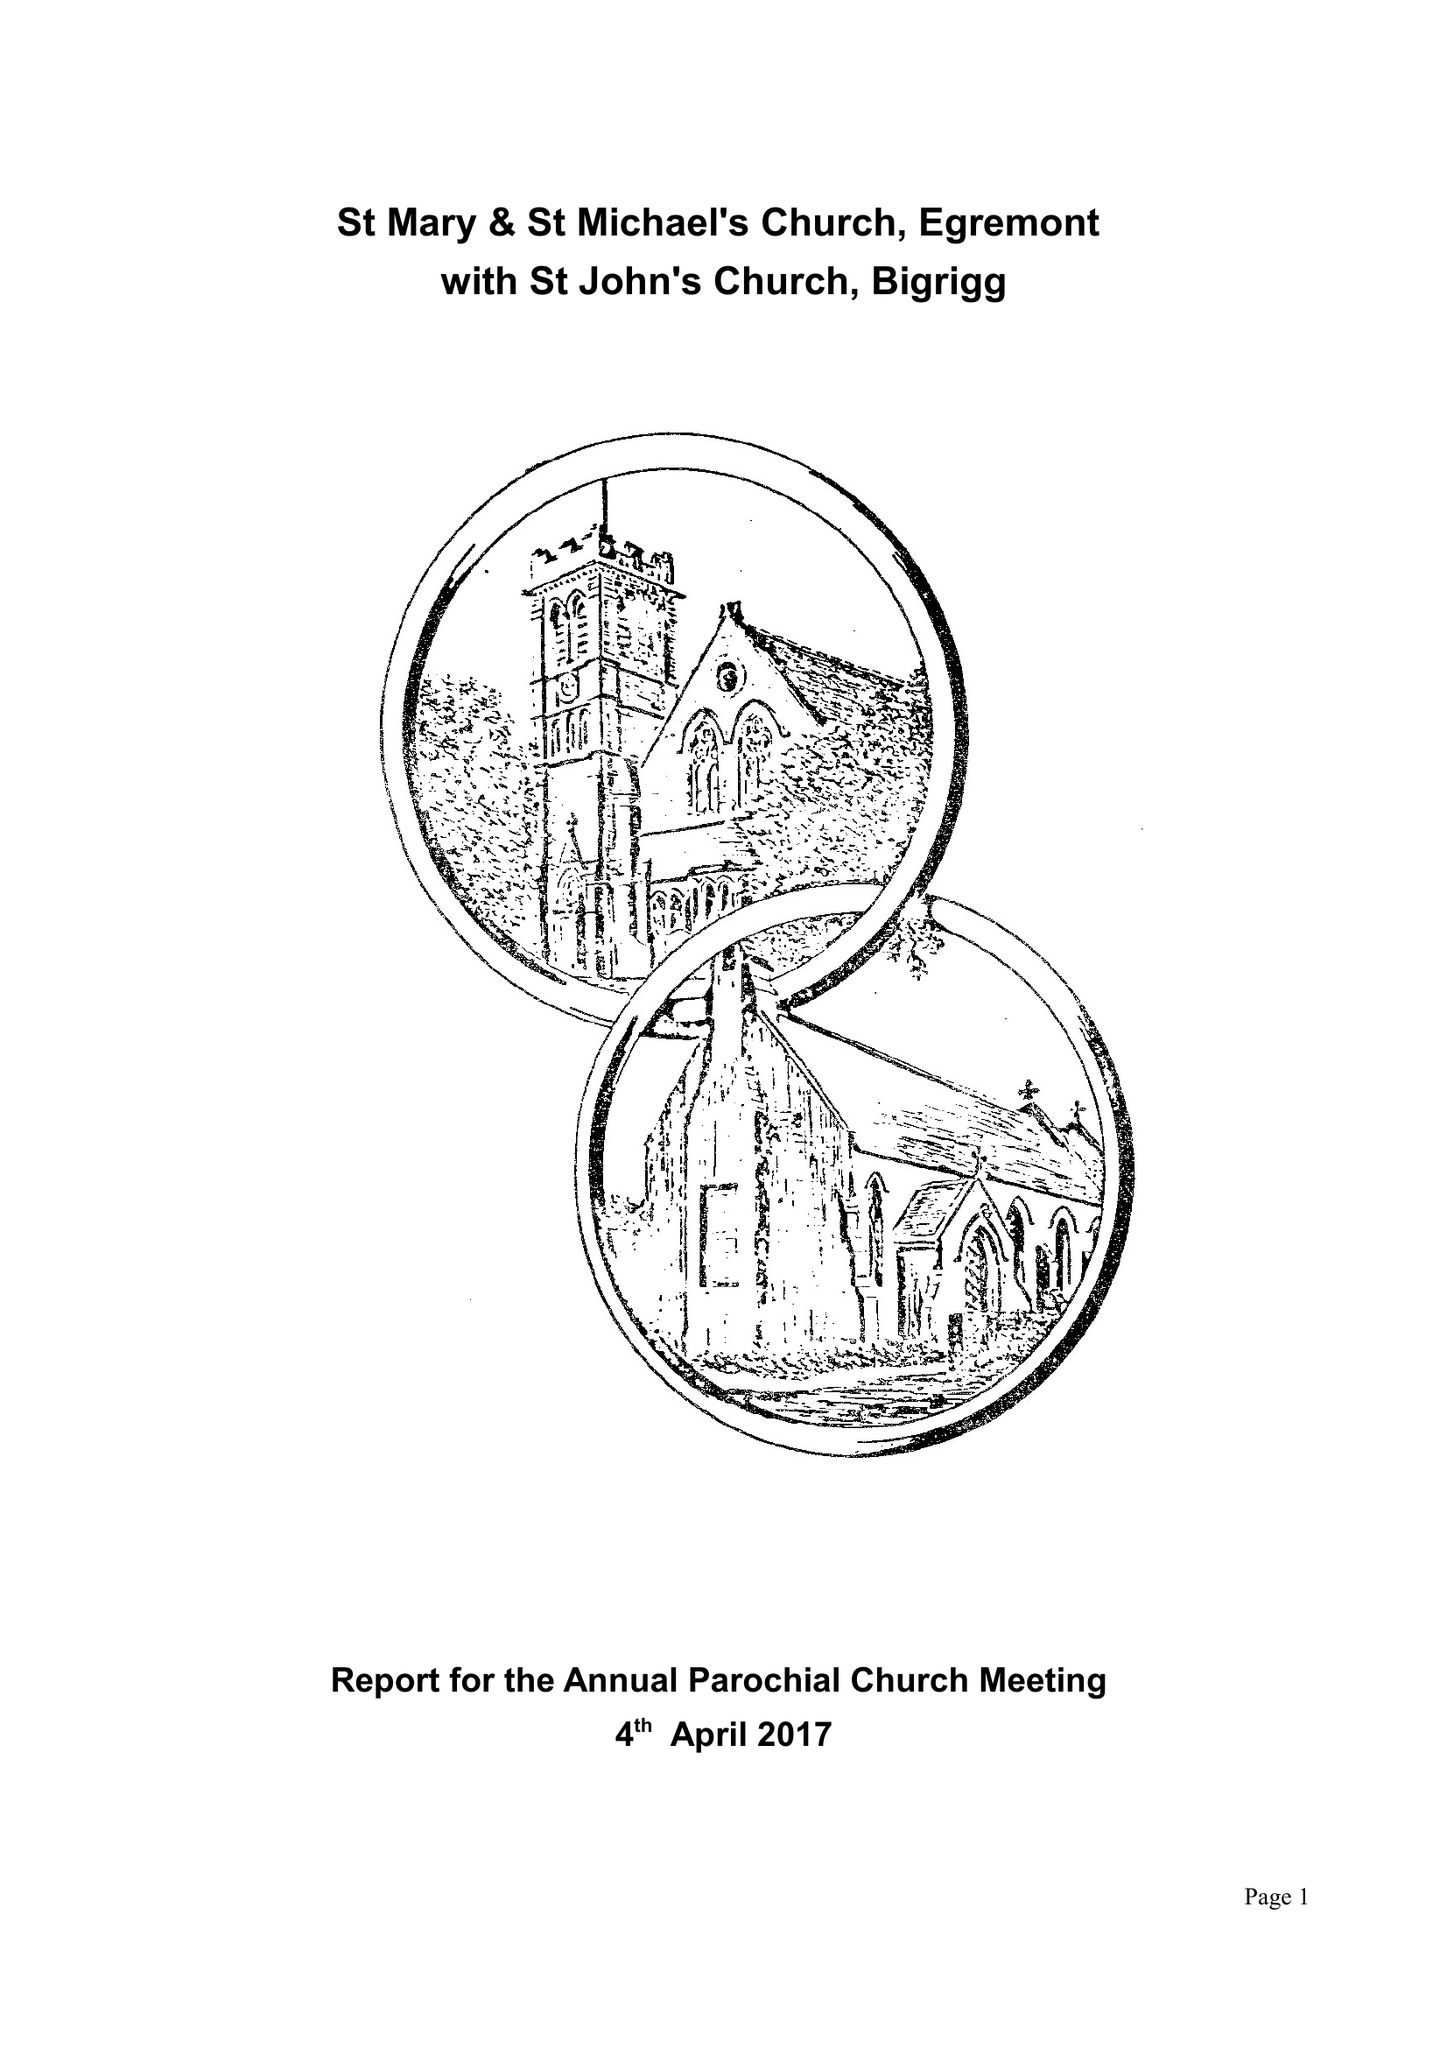What is the value for the address__street_line?
Answer the question using a single word or phrase. 12 RIVERSIDE DRIVE 